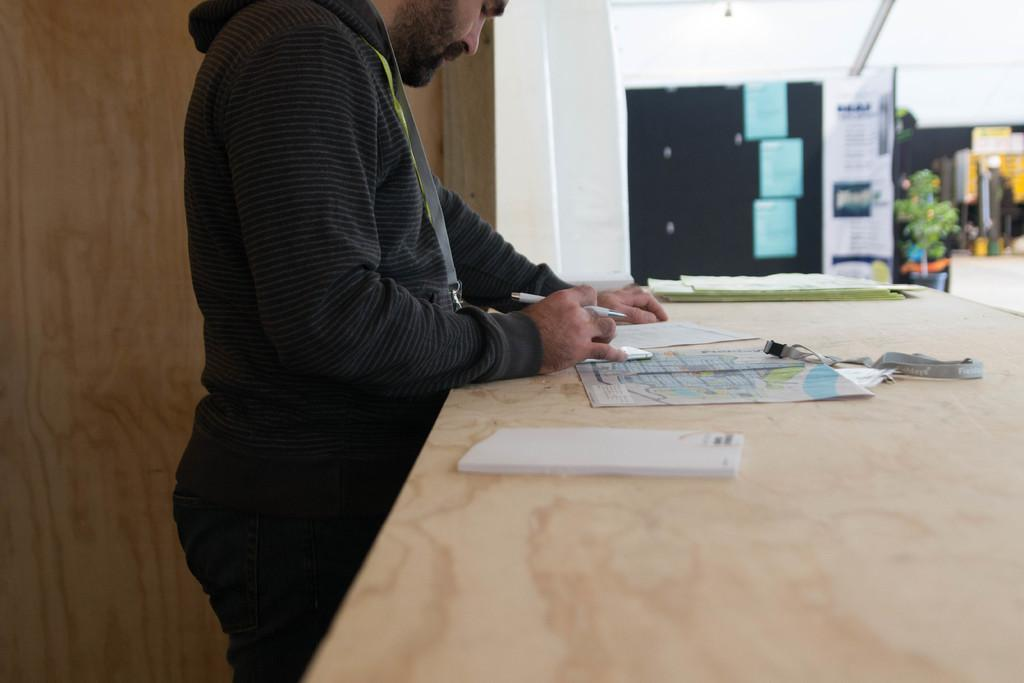What is the person in the image doing? The person is standing in the image and holding a pen in their hands. What is in front of the person? There is a table in front of the person. What is on the table? There are papers and other objects on the table. Can you tell me how many basketballs are on the table in the image? There are no basketballs present in the image. What type of feeling does the person in the image seem to be experiencing? The image does not convey any specific feelings or emotions of the person, so it cannot be determined from the image. 